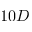<formula> <loc_0><loc_0><loc_500><loc_500>1 0 D</formula> 